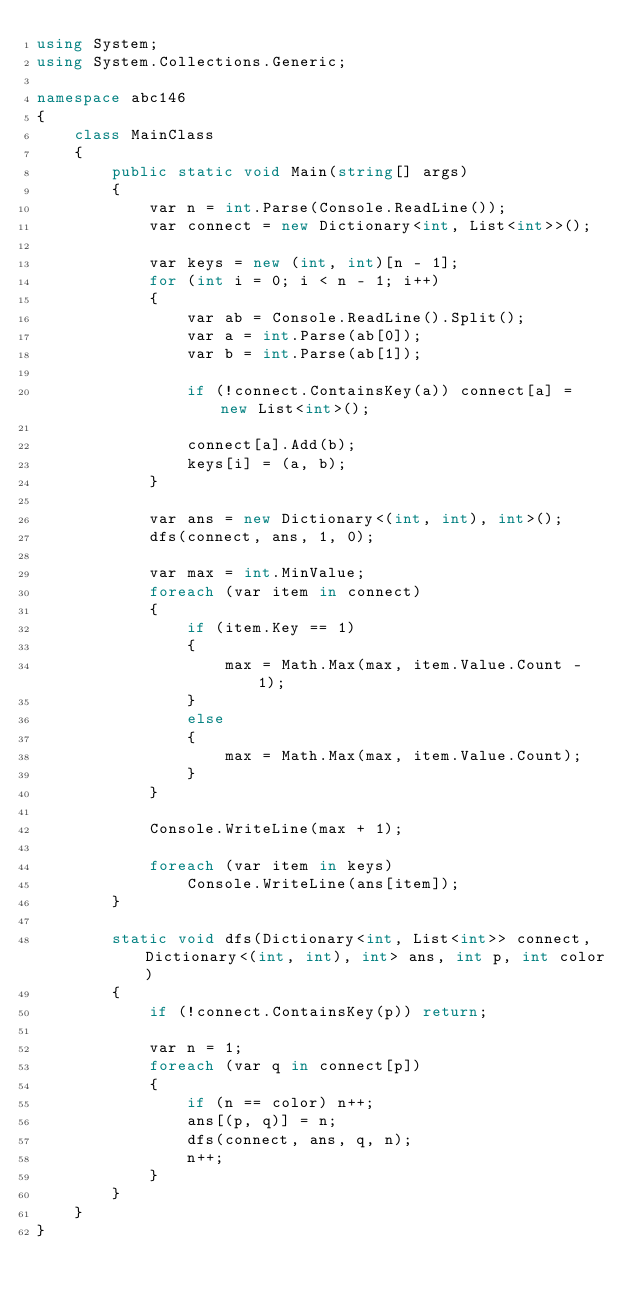<code> <loc_0><loc_0><loc_500><loc_500><_C#_>using System;
using System.Collections.Generic;

namespace abc146
{
    class MainClass
    {
        public static void Main(string[] args)
        {
            var n = int.Parse(Console.ReadLine());
            var connect = new Dictionary<int, List<int>>();

            var keys = new (int, int)[n - 1];
            for (int i = 0; i < n - 1; i++)
            {
                var ab = Console.ReadLine().Split();
                var a = int.Parse(ab[0]);
                var b = int.Parse(ab[1]);

                if (!connect.ContainsKey(a)) connect[a] = new List<int>();

                connect[a].Add(b);
                keys[i] = (a, b);
            }

            var ans = new Dictionary<(int, int), int>();
            dfs(connect, ans, 1, 0);

            var max = int.MinValue;
            foreach (var item in connect)
            {
                if (item.Key == 1)
                {
                    max = Math.Max(max, item.Value.Count - 1);
                }
                else
                {
                    max = Math.Max(max, item.Value.Count);
                }
            }

            Console.WriteLine(max + 1);

            foreach (var item in keys)
                Console.WriteLine(ans[item]);
        }

        static void dfs(Dictionary<int, List<int>> connect, Dictionary<(int, int), int> ans, int p, int color)
        {
            if (!connect.ContainsKey(p)) return;

            var n = 1;
            foreach (var q in connect[p])
            {
                if (n == color) n++;
                ans[(p, q)] = n;
                dfs(connect, ans, q, n);
                n++;
            }
        }
    }
}
</code> 